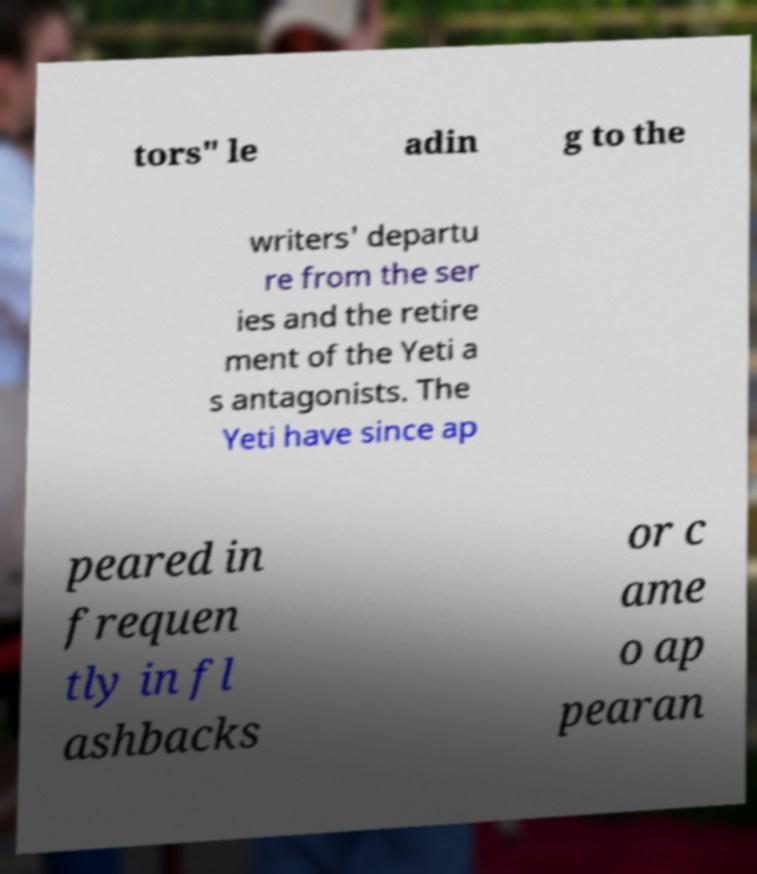Could you assist in decoding the text presented in this image and type it out clearly? tors" le adin g to the writers' departu re from the ser ies and the retire ment of the Yeti a s antagonists. The Yeti have since ap peared in frequen tly in fl ashbacks or c ame o ap pearan 